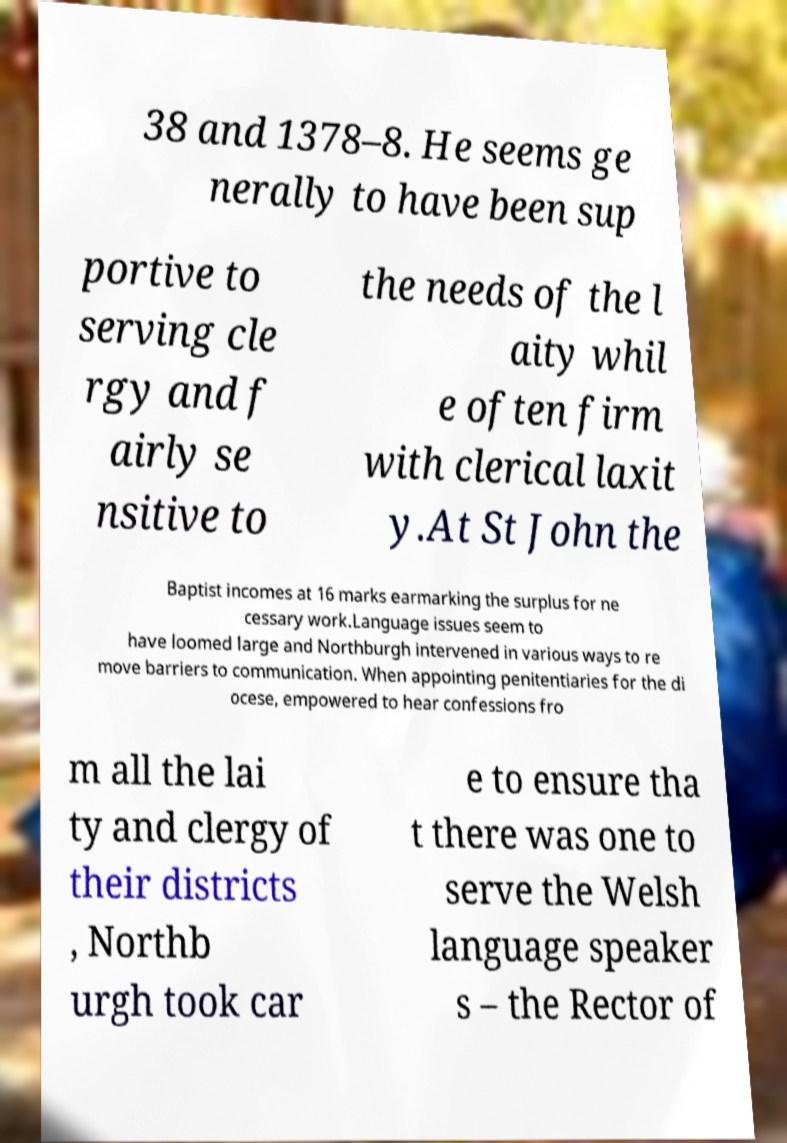Can you accurately transcribe the text from the provided image for me? 38 and 1378–8. He seems ge nerally to have been sup portive to serving cle rgy and f airly se nsitive to the needs of the l aity whil e often firm with clerical laxit y.At St John the Baptist incomes at 16 marks earmarking the surplus for ne cessary work.Language issues seem to have loomed large and Northburgh intervened in various ways to re move barriers to communication. When appointing penitentiaries for the di ocese, empowered to hear confessions fro m all the lai ty and clergy of their districts , Northb urgh took car e to ensure tha t there was one to serve the Welsh language speaker s – the Rector of 